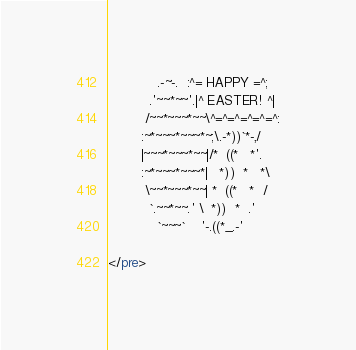<code> <loc_0><loc_0><loc_500><loc_500><_HTML_>            .-~-.  :^= HAPPY =^;
          .'~~*~~'.|^ EASTER! ^|
         /~~*~~~*~~\^=^=^=^=^=^:
        :~*~~~*~~~*~;\.-*))`*-,/
        |~~~*~~~*~~|/*  ((*   *'.
        :~*~~~*~~~*|   *))  *   *\
         \~~*~~~*~~| *  ((*   *  /
          `.~~*~~.' \  *))  *  .'
            `~~~`    '-.((*_.-'

</pre>
</code> 